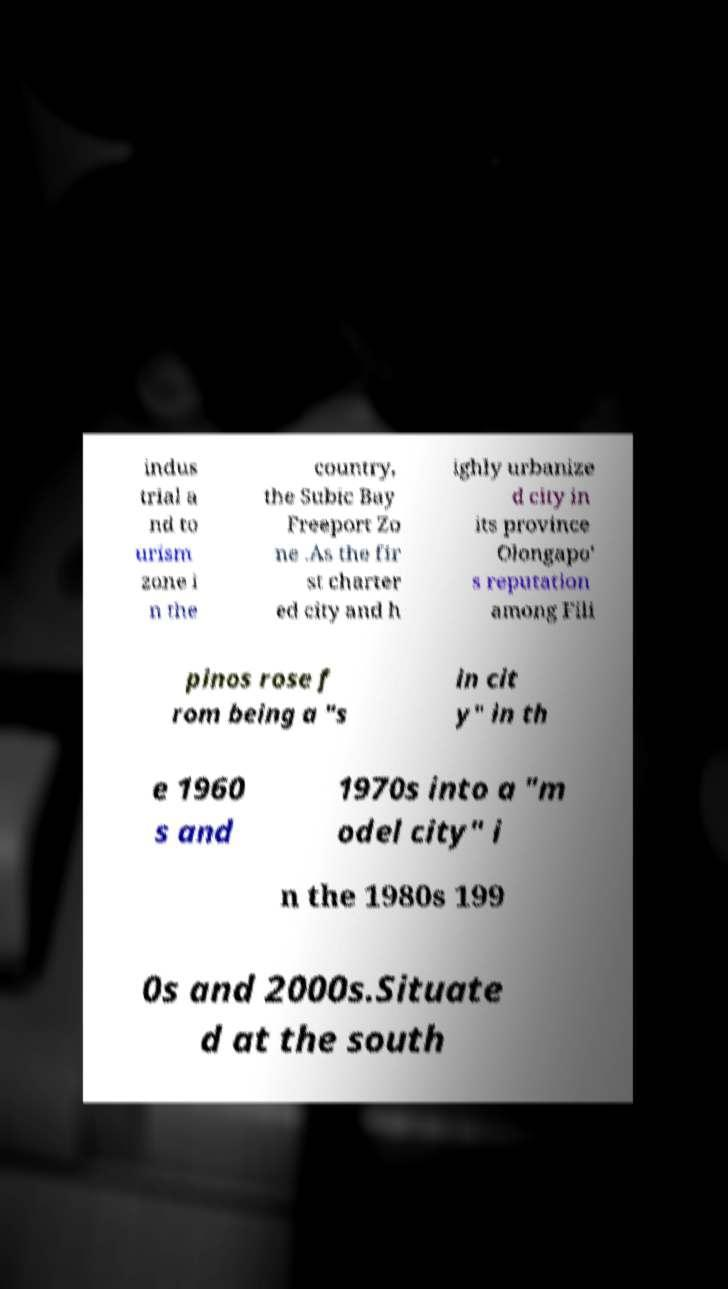I need the written content from this picture converted into text. Can you do that? indus trial a nd to urism zone i n the country, the Subic Bay Freeport Zo ne .As the fir st charter ed city and h ighly urbanize d city in its province Olongapo' s reputation among Fili pinos rose f rom being a "s in cit y" in th e 1960 s and 1970s into a "m odel city" i n the 1980s 199 0s and 2000s.Situate d at the south 